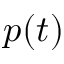<formula> <loc_0><loc_0><loc_500><loc_500>p ( t )</formula> 